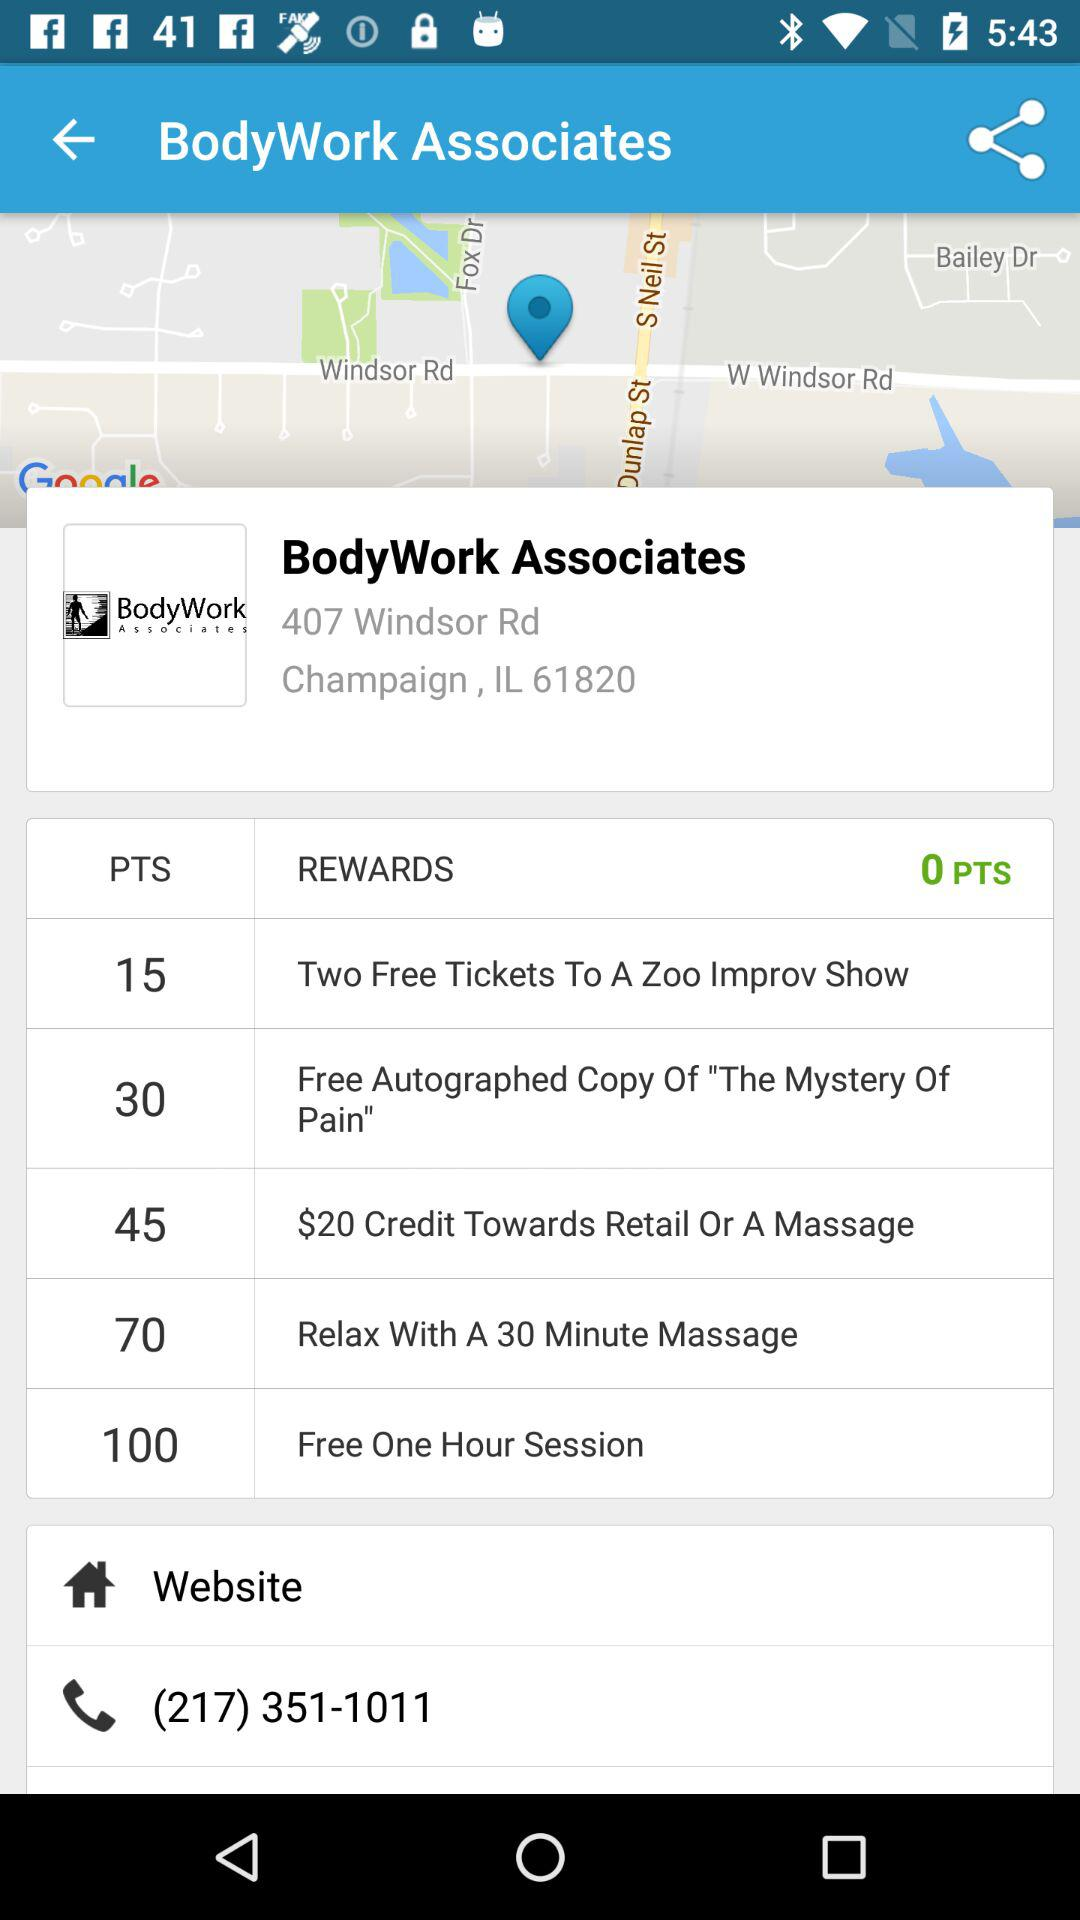How many rewards does the user have?
Answer the question using a single word or phrase. 0 